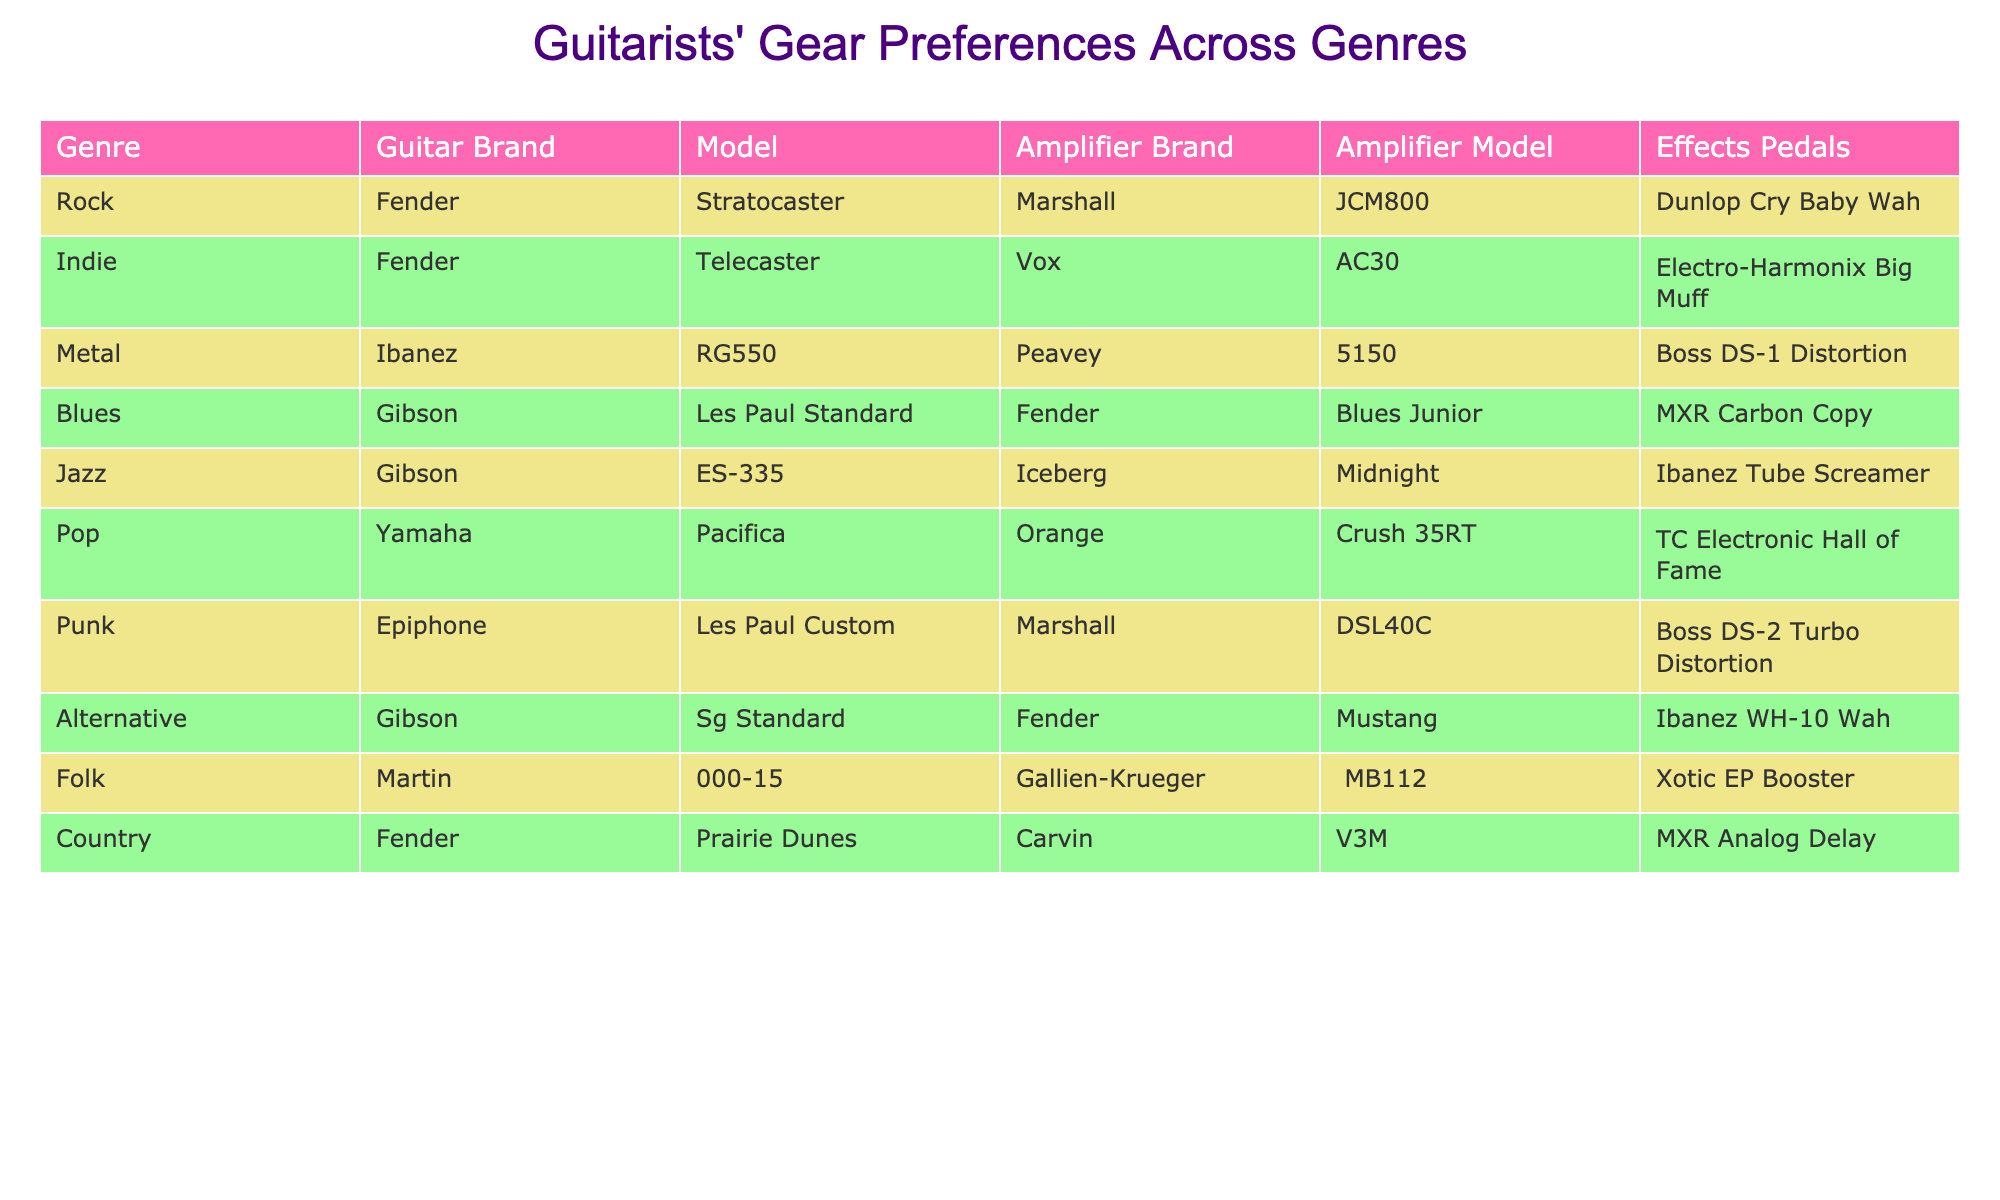What guitar model is typically used in Blues? According to the table, the guitar model used in Blues is the Gibson Les Paul Standard.
Answer: Gibson Les Paul Standard Which amplifier is associated with Rock genre? The table indicates that the amplifier used in the Rock genre is the Marshall JCM800.
Answer: Marshall JCM800 True or False: The Pop genre uses a Fender guitar brand. Looking at the table, the Pop genre uses a Yamaha guitar brand, not Fender. Therefore, the statement is false.
Answer: False Which genres use effects pedals from Boss? From the table, Boss effects pedals are used in two genres: Metal (Boss DS-1 Distortion) and Punk (Boss DS-2 Turbo Distortion).
Answer: Metal and Punk What is the total number of unique guitar brands listed in the table? By checking the table, the unique guitar brands are Fender, Ibanez, Gibson, Yamaha, Epiphone, and Martin. There are a total of 6 unique brands.
Answer: 6 Which amplifier brand is most commonly paired with Gibson guitars? The table shows that Gibson guitars are paired with two different amplifier brands: Iceberg (for Jazz) and Fender (for Alternative). Since both are only paired once, neither is more common than the other.
Answer: Both are equally common What is the differences in the amplifier models used between Country and Folk genres? The Folk genre uses the Gallien-Krueger MB112 amplifier while the Country genre uses the Carvin V3M amplifier. The difference is that they are from different brands altogether (Gallien-Krueger vs. Carvin) and feature different models.
Answer: Different brands and models What is the average number of effects pedals used across all genres? The table lists effects pedals for all 10 genres. Therefore, the average is calculated as 10 (number of genres) divided by 10 (effects pedals listed). Thus, the average is 1.
Answer: 1 Which genre has the most unique combination of gear, considering guitar, amplifier brand, and effects pedals? To find the genre with the most unique combination, we need to look at guitar, amplifier brand, and effects pedals. After reviewing, we find that each genre has distinct options, but since all entries are unique, they all have an equal count.
Answer: All genres are unique 